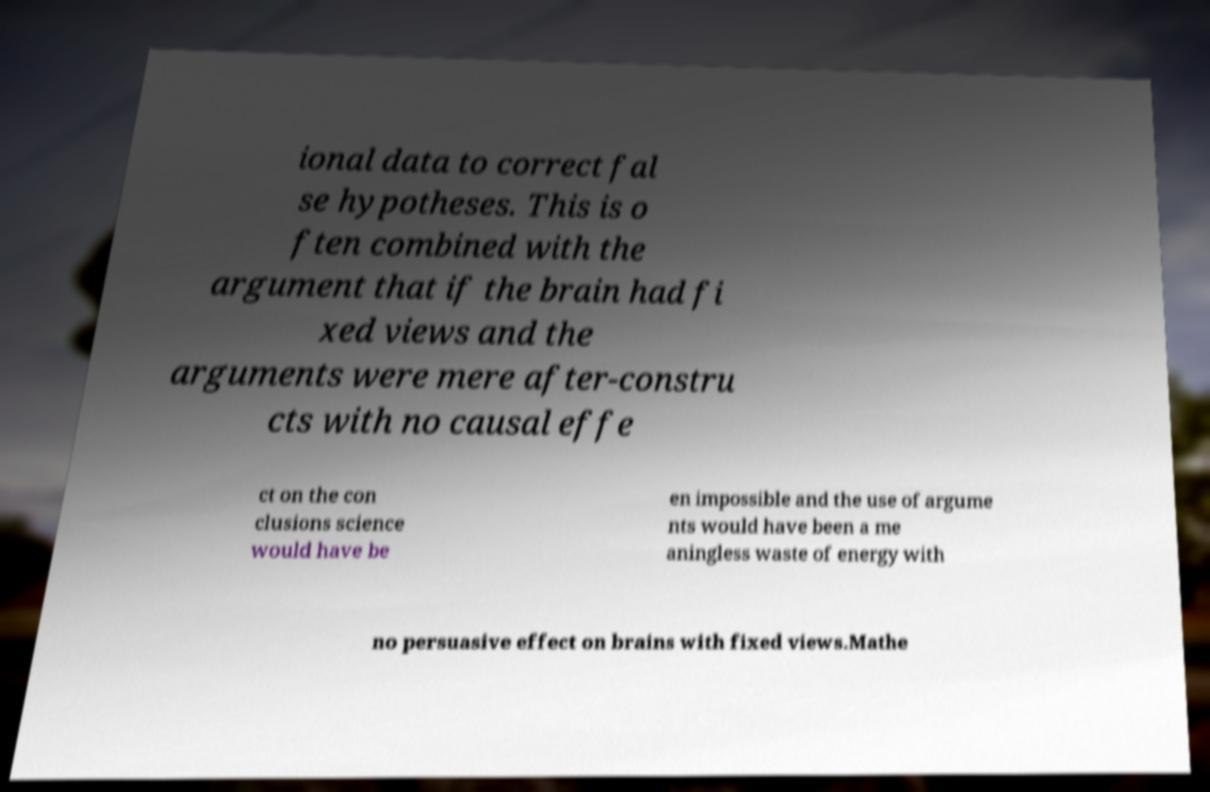I need the written content from this picture converted into text. Can you do that? ional data to correct fal se hypotheses. This is o ften combined with the argument that if the brain had fi xed views and the arguments were mere after-constru cts with no causal effe ct on the con clusions science would have be en impossible and the use of argume nts would have been a me aningless waste of energy with no persuasive effect on brains with fixed views.Mathe 